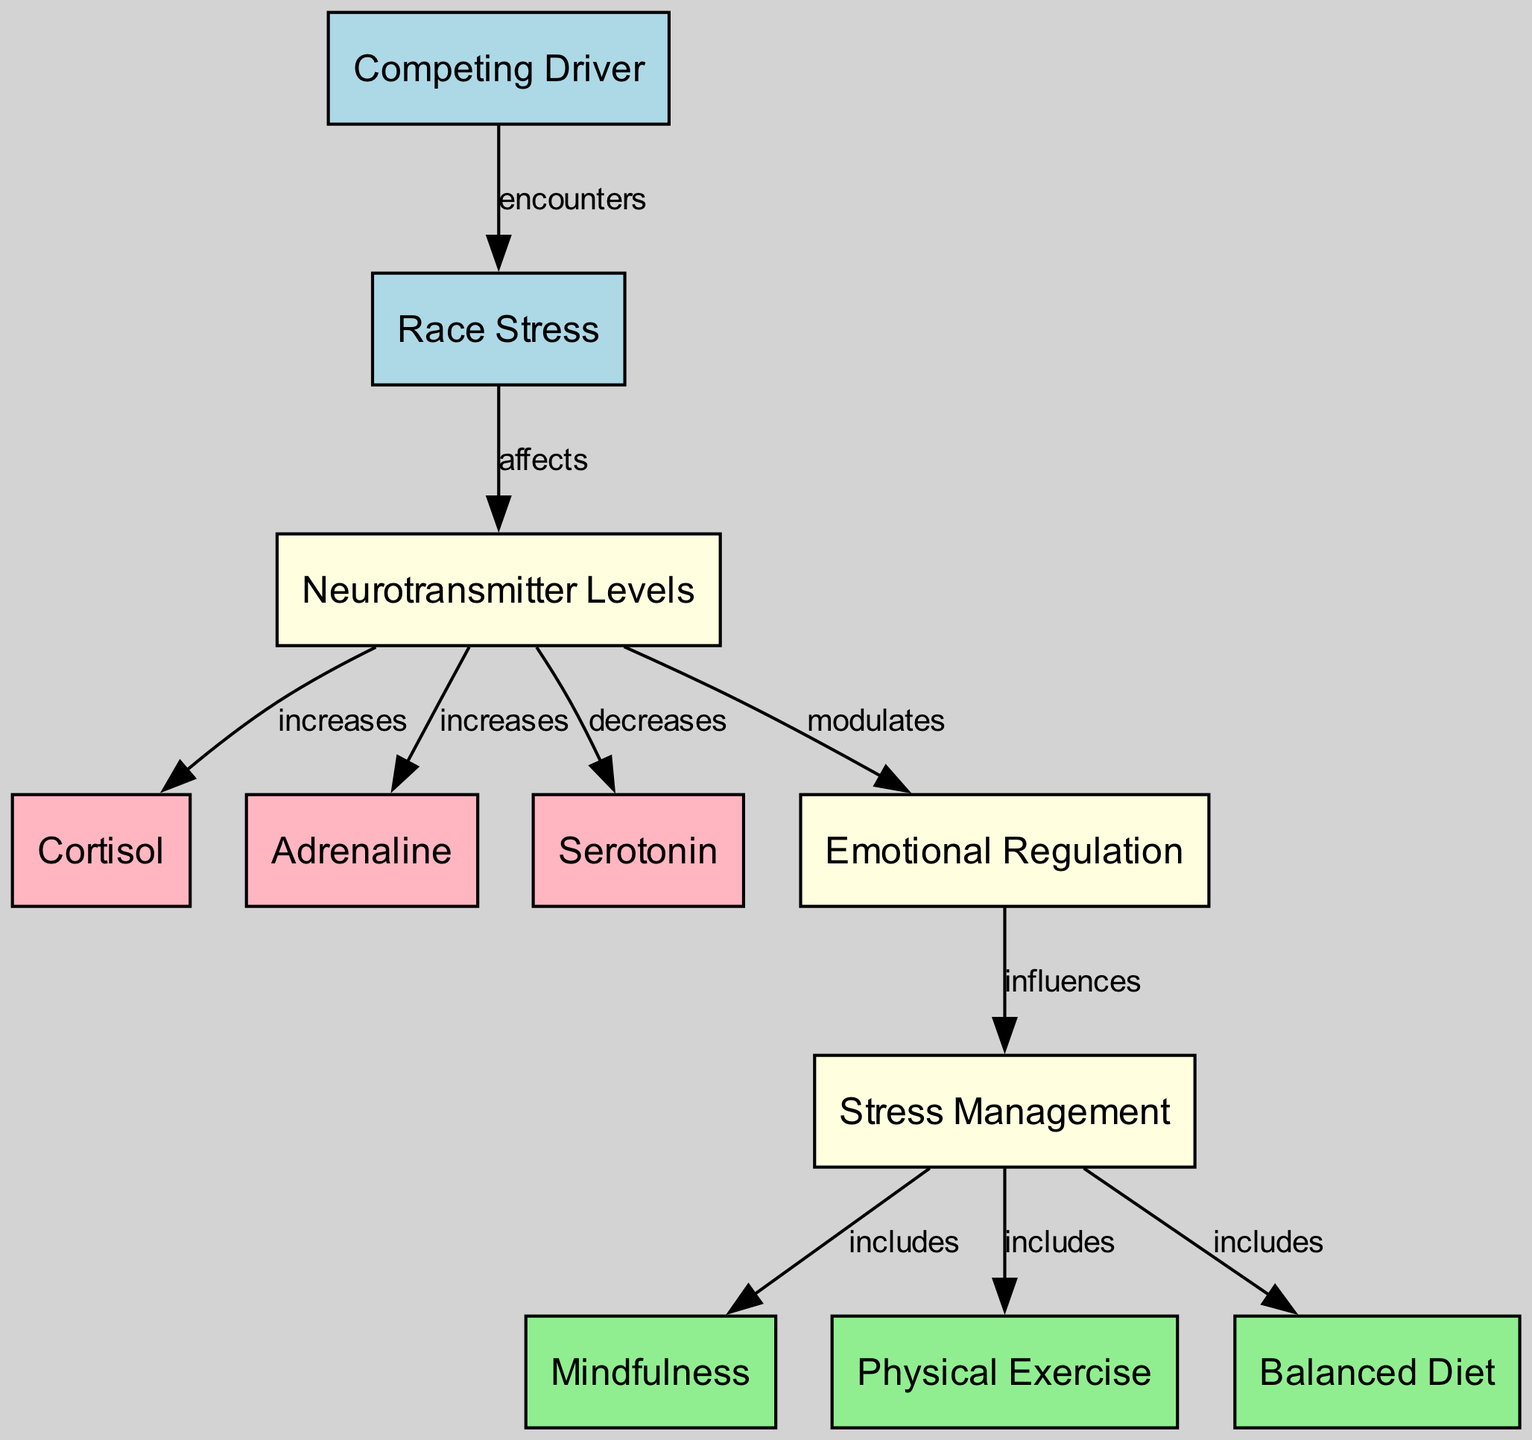What node does the Competing Driver connect to? The Competing Driver node has an edge that connects it to the Race Stress node, indicating that the driver encounters race stress.
Answer: Race Stress How many total nodes are present in the diagram? By counting the distinct nodes, we find that there are 11 different nodes represented in the diagram.
Answer: 11 Which neurotransmitter level is affected by Race Stress and decreases? According to the edges in the diagram, Race Stress affects Neurotransmitter Levels, which subsequently sees a decrease in the Serotonin level.
Answer: Serotonin What is included in Stress Management? The diagram indicates that Stress Management includes several components, specifically Mindfulness, Physical Exercise, and Balanced Diet, showing how these elements contribute to overall stress management for drivers.
Answer: Mindfulness, Physical Exercise, Balanced Diet How does Emotional Regulation relate to Stress Management? The diagram depicts an edge from Emotional Regulation to Stress Management, signifying that emotional regulation influences the approach and effectiveness of stress management techniques for drivers.
Answer: influences What happens to Cortisol and Adrenaline levels under stress? Analyzing the relationships, it’s clear that both Cortisol and Adrenaline levels increase due to Race Stress affecting Neurotransmitter Levels. Therefore, they are both positively impacted by stress.
Answer: increases Which node modulates Emotional Regulation? The Neurotransmitter Levels node is connected to the Emotional Regulation node, indicating that neurotransmitter levels play a crucial role in modulating emotional regulation during stressful events like racing.
Answer: Neurotransmitter Levels What does the edge from Neurotransmitter Levels to Emotional Regulation imply? This edge signifies that changes in neurotransmitter levels due to stress have a direct influence on how emotional regulation is managed by the driver, suggesting a link between physiological and psychological states.
Answer: modulates In the context of the diagram, what does the edge from Race Stress to Neurotransmitter Levels indicate? This edge implies that experiencing race stress directly affects the neurotransmitter levels in drivers, showcasing the physiological impact of competitive racing scenarios.
Answer: affects 